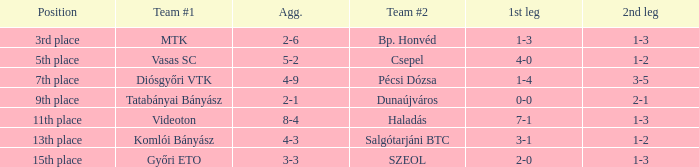What is the initial leg with a 4-3 aggregate? 3-1. 